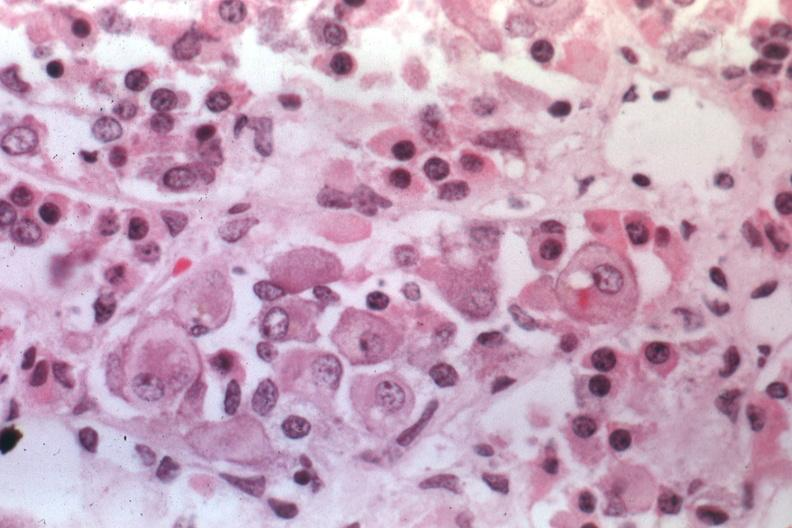what is present?
Answer the question using a single word or phrase. Endocrine 